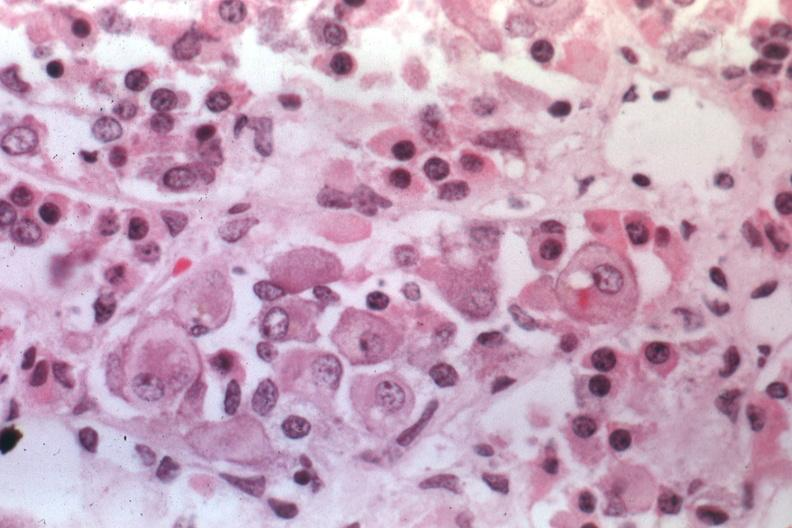what is present?
Answer the question using a single word or phrase. Endocrine 